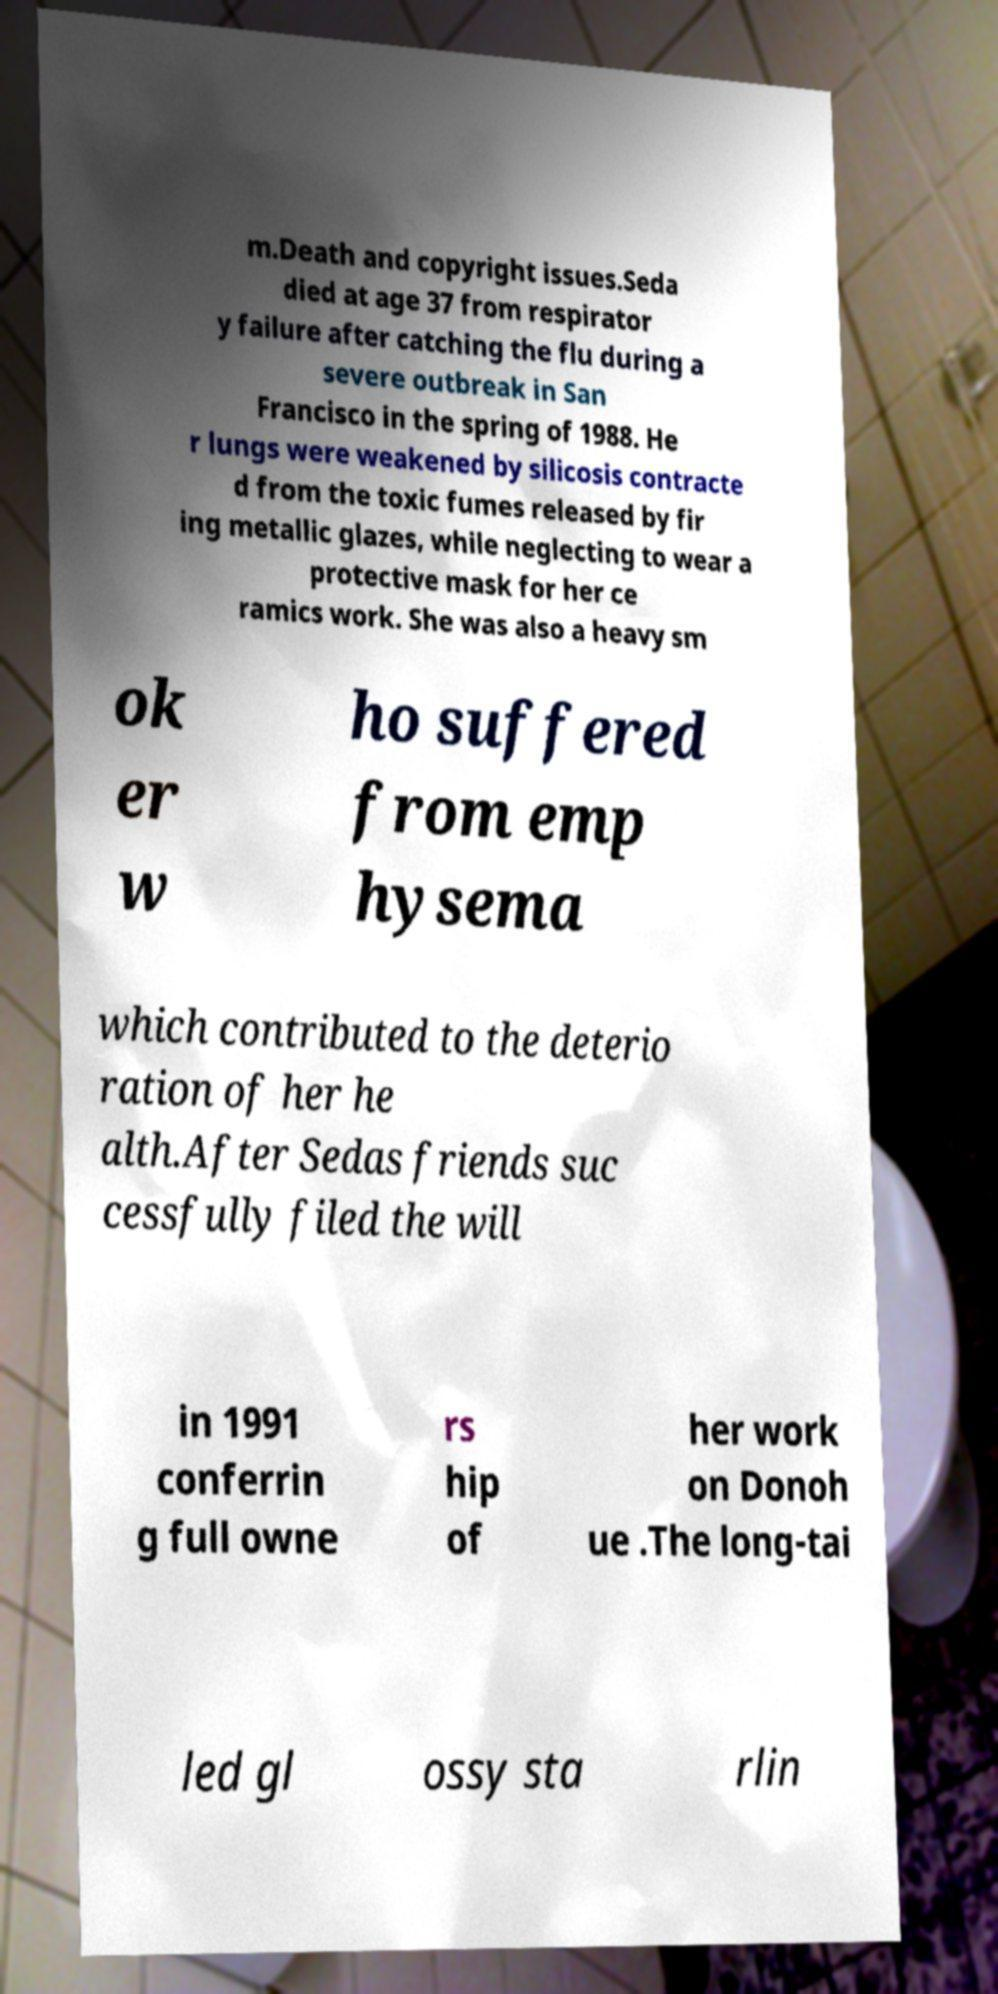For documentation purposes, I need the text within this image transcribed. Could you provide that? m.Death and copyright issues.Seda died at age 37 from respirator y failure after catching the flu during a severe outbreak in San Francisco in the spring of 1988. He r lungs were weakened by silicosis contracte d from the toxic fumes released by fir ing metallic glazes, while neglecting to wear a protective mask for her ce ramics work. She was also a heavy sm ok er w ho suffered from emp hysema which contributed to the deterio ration of her he alth.After Sedas friends suc cessfully filed the will in 1991 conferrin g full owne rs hip of her work on Donoh ue .The long-tai led gl ossy sta rlin 